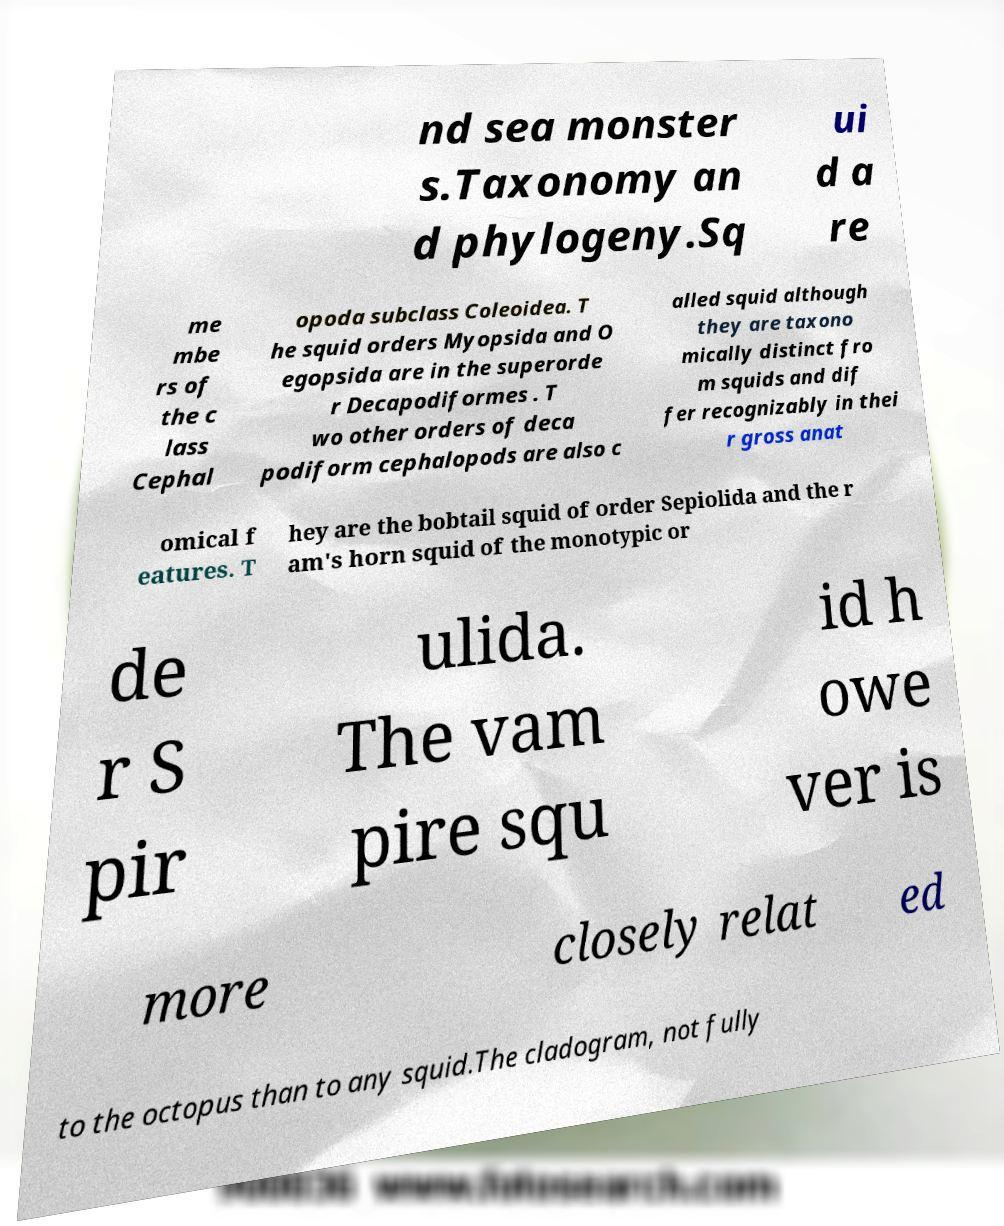For documentation purposes, I need the text within this image transcribed. Could you provide that? nd sea monster s.Taxonomy an d phylogeny.Sq ui d a re me mbe rs of the c lass Cephal opoda subclass Coleoidea. T he squid orders Myopsida and O egopsida are in the superorde r Decapodiformes . T wo other orders of deca podiform cephalopods are also c alled squid although they are taxono mically distinct fro m squids and dif fer recognizably in thei r gross anat omical f eatures. T hey are the bobtail squid of order Sepiolida and the r am's horn squid of the monotypic or de r S pir ulida. The vam pire squ id h owe ver is more closely relat ed to the octopus than to any squid.The cladogram, not fully 